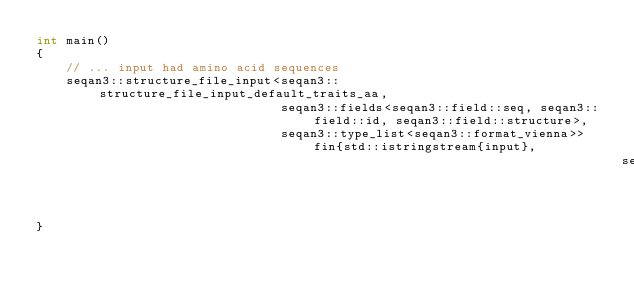<code> <loc_0><loc_0><loc_500><loc_500><_C++_>int main()
{
    // ... input had amino acid sequences
    seqan3::structure_file_input<seqan3::structure_file_input_default_traits_aa,
                                 seqan3::fields<seqan3::field::seq, seqan3::field::id, seqan3::field::structure>,
                                 seqan3::type_list<seqan3::format_vienna>> fin{std::istringstream{input},
                                                                               seqan3::format_vienna{}};
}
</code> 